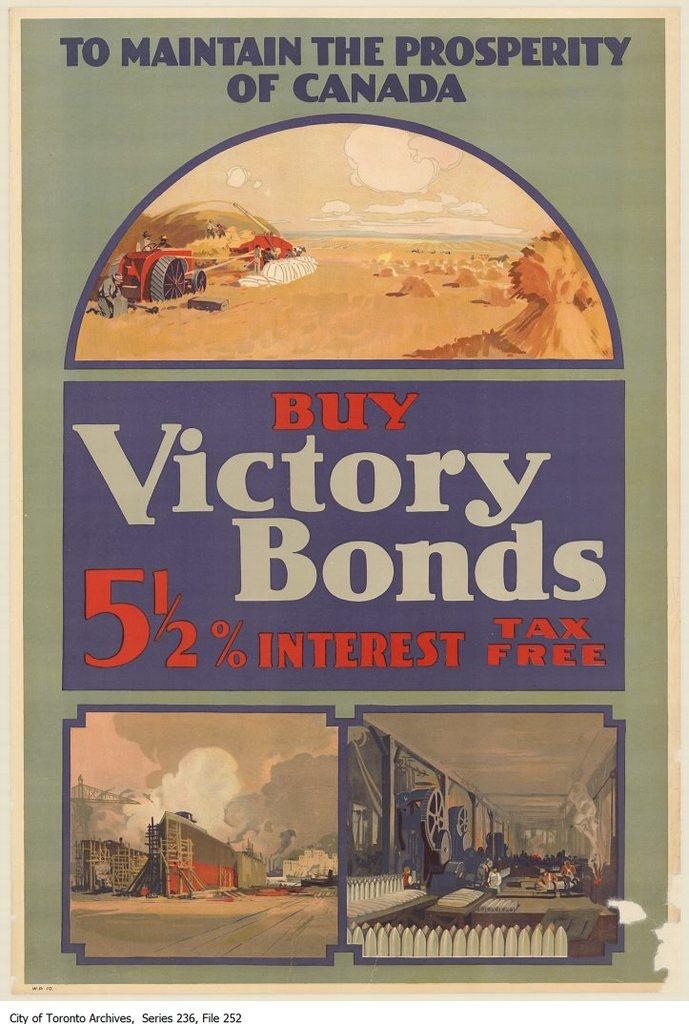Provide a one-sentence caption for the provided image. A poster for Canadian victory bonds has drawings of a farmer, a building, and a factory on it. 